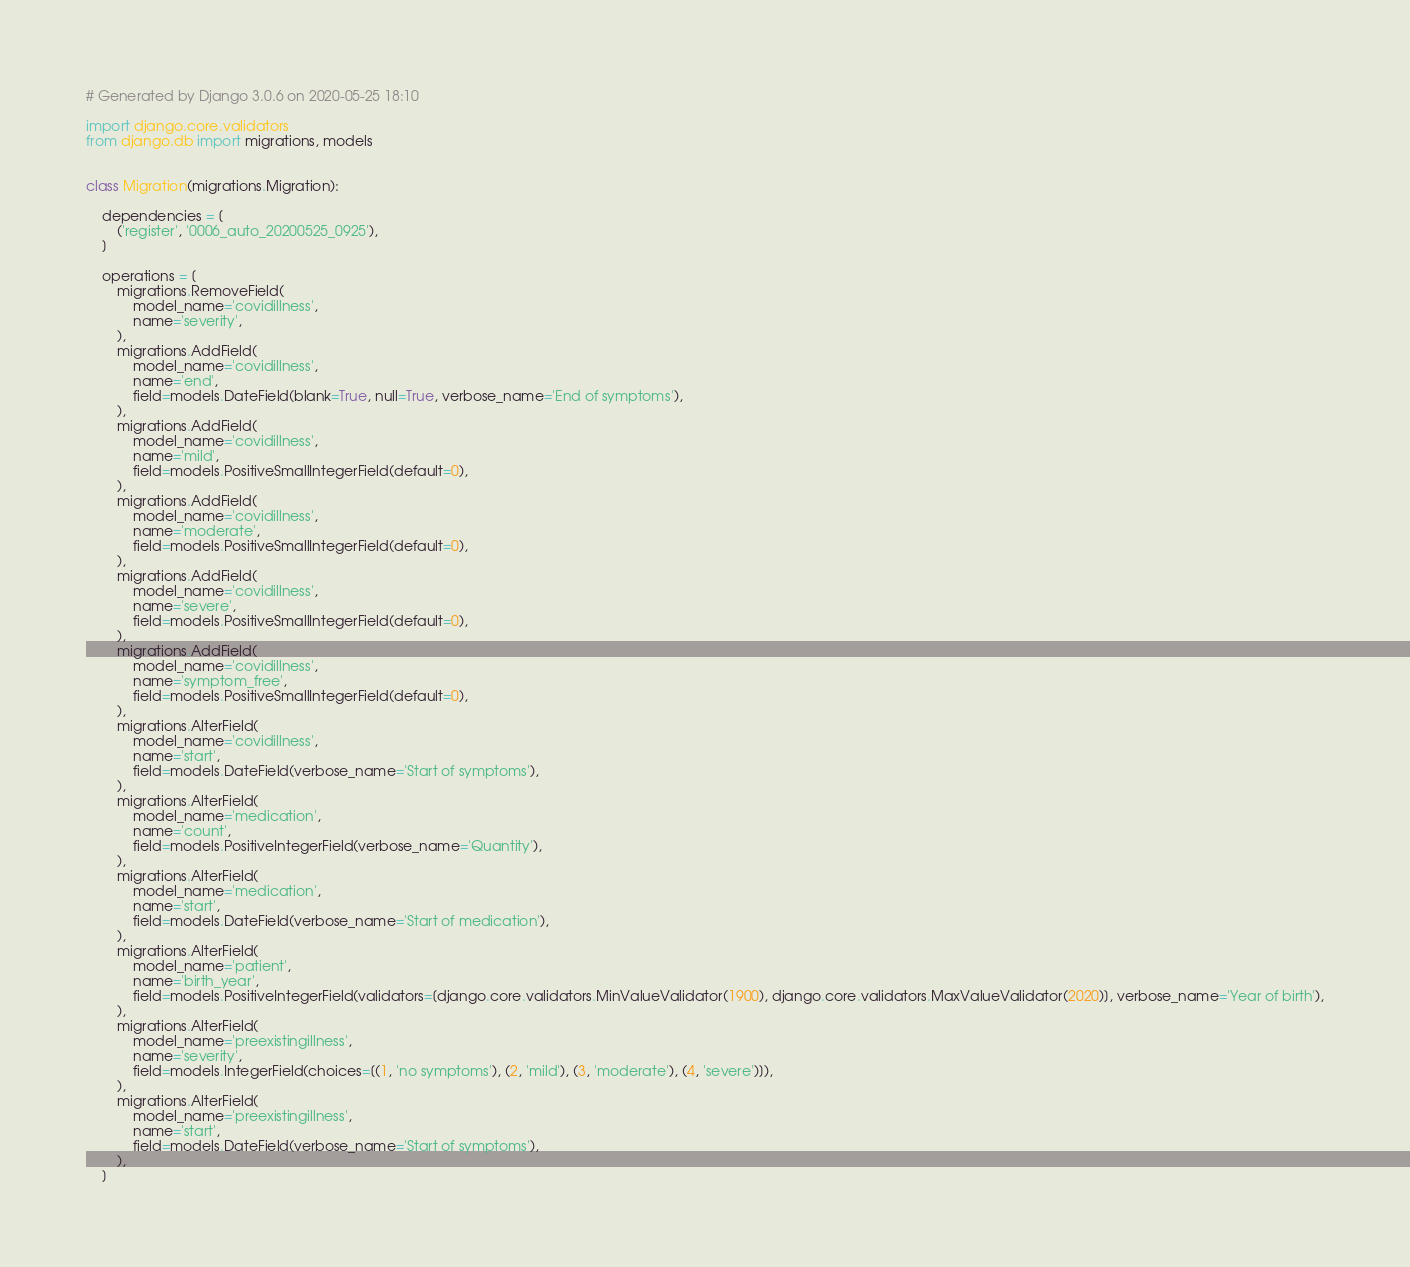<code> <loc_0><loc_0><loc_500><loc_500><_Python_># Generated by Django 3.0.6 on 2020-05-25 18:10

import django.core.validators
from django.db import migrations, models


class Migration(migrations.Migration):

    dependencies = [
        ('register', '0006_auto_20200525_0925'),
    ]

    operations = [
        migrations.RemoveField(
            model_name='covidillness',
            name='severity',
        ),
        migrations.AddField(
            model_name='covidillness',
            name='end',
            field=models.DateField(blank=True, null=True, verbose_name='End of symptoms'),
        ),
        migrations.AddField(
            model_name='covidillness',
            name='mild',
            field=models.PositiveSmallIntegerField(default=0),
        ),
        migrations.AddField(
            model_name='covidillness',
            name='moderate',
            field=models.PositiveSmallIntegerField(default=0),
        ),
        migrations.AddField(
            model_name='covidillness',
            name='severe',
            field=models.PositiveSmallIntegerField(default=0),
        ),
        migrations.AddField(
            model_name='covidillness',
            name='symptom_free',
            field=models.PositiveSmallIntegerField(default=0),
        ),
        migrations.AlterField(
            model_name='covidillness',
            name='start',
            field=models.DateField(verbose_name='Start of symptoms'),
        ),
        migrations.AlterField(
            model_name='medication',
            name='count',
            field=models.PositiveIntegerField(verbose_name='Quantity'),
        ),
        migrations.AlterField(
            model_name='medication',
            name='start',
            field=models.DateField(verbose_name='Start of medication'),
        ),
        migrations.AlterField(
            model_name='patient',
            name='birth_year',
            field=models.PositiveIntegerField(validators=[django.core.validators.MinValueValidator(1900), django.core.validators.MaxValueValidator(2020)], verbose_name='Year of birth'),
        ),
        migrations.AlterField(
            model_name='preexistingillness',
            name='severity',
            field=models.IntegerField(choices=[(1, 'no symptoms'), (2, 'mild'), (3, 'moderate'), (4, 'severe')]),
        ),
        migrations.AlterField(
            model_name='preexistingillness',
            name='start',
            field=models.DateField(verbose_name='Start of symptoms'),
        ),
    ]
</code> 